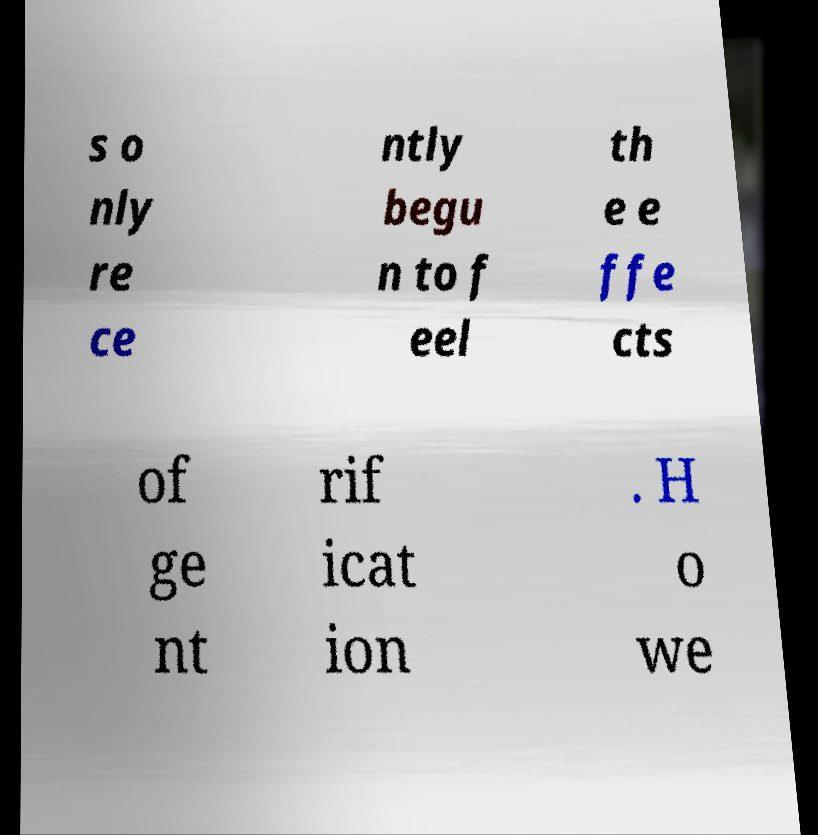For documentation purposes, I need the text within this image transcribed. Could you provide that? s o nly re ce ntly begu n to f eel th e e ffe cts of ge nt rif icat ion . H o we 